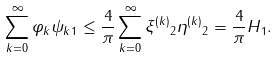Convert formula to latex. <formula><loc_0><loc_0><loc_500><loc_500>\| \sum _ { k = 0 } ^ { \infty } \varphi _ { k } \psi _ { k } \| _ { 1 } \leq \frac { 4 } { \pi } \sum _ { k = 0 } ^ { \infty } \| \xi ^ { ( k ) } \| _ { 2 } \| \eta ^ { ( k ) } \| _ { 2 } = \frac { 4 } { \pi } \| H \| _ { 1 } .</formula> 